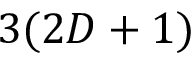<formula> <loc_0><loc_0><loc_500><loc_500>3 ( 2 D + 1 )</formula> 